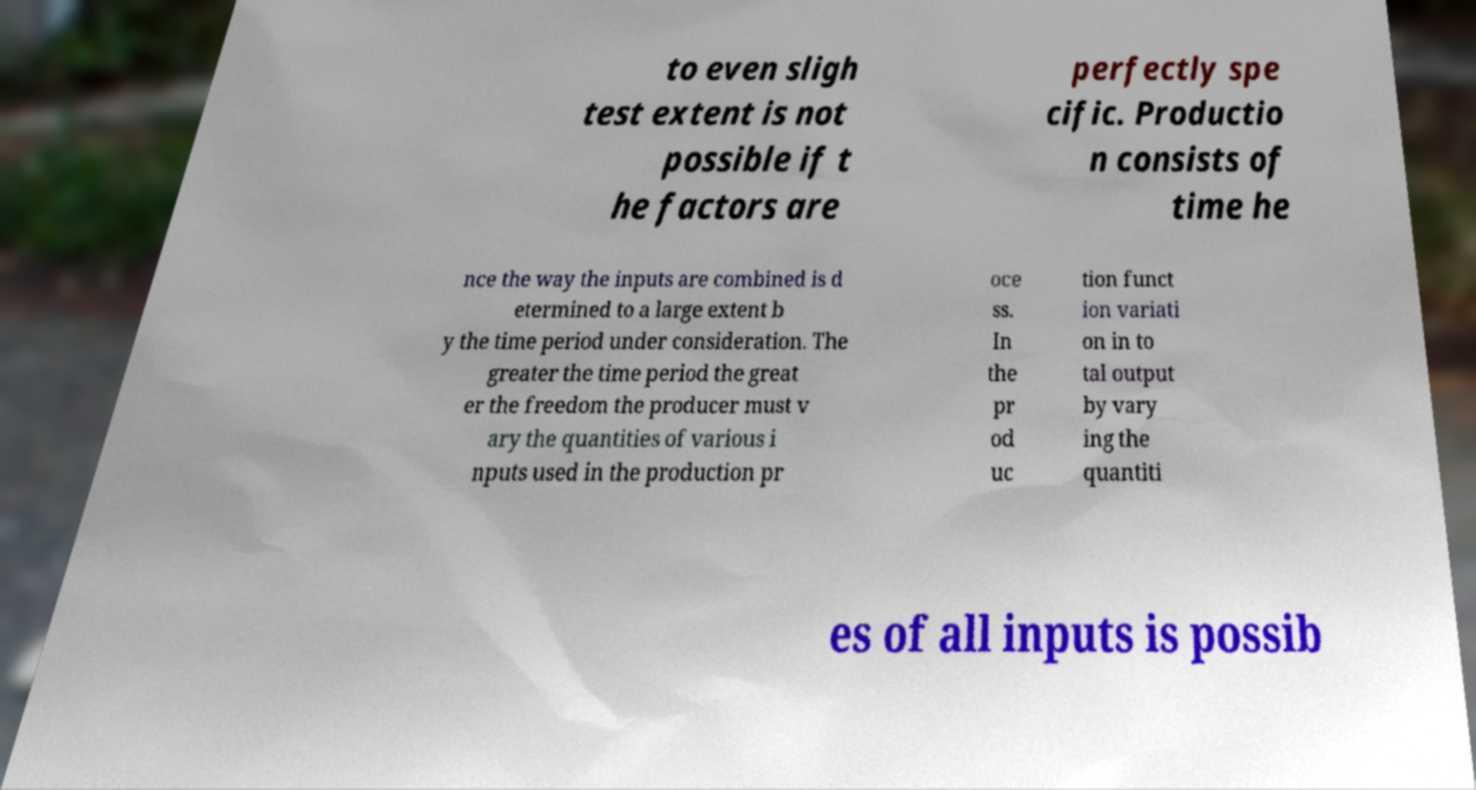Please identify and transcribe the text found in this image. to even sligh test extent is not possible if t he factors are perfectly spe cific. Productio n consists of time he nce the way the inputs are combined is d etermined to a large extent b y the time period under consideration. The greater the time period the great er the freedom the producer must v ary the quantities of various i nputs used in the production pr oce ss. In the pr od uc tion funct ion variati on in to tal output by vary ing the quantiti es of all inputs is possib 